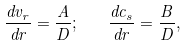Convert formula to latex. <formula><loc_0><loc_0><loc_500><loc_500>\frac { d v _ { r } } { d r } = \frac { A } { D } ; \quad \frac { d c _ { s } } { d r } = \frac { B } { D } ,</formula> 